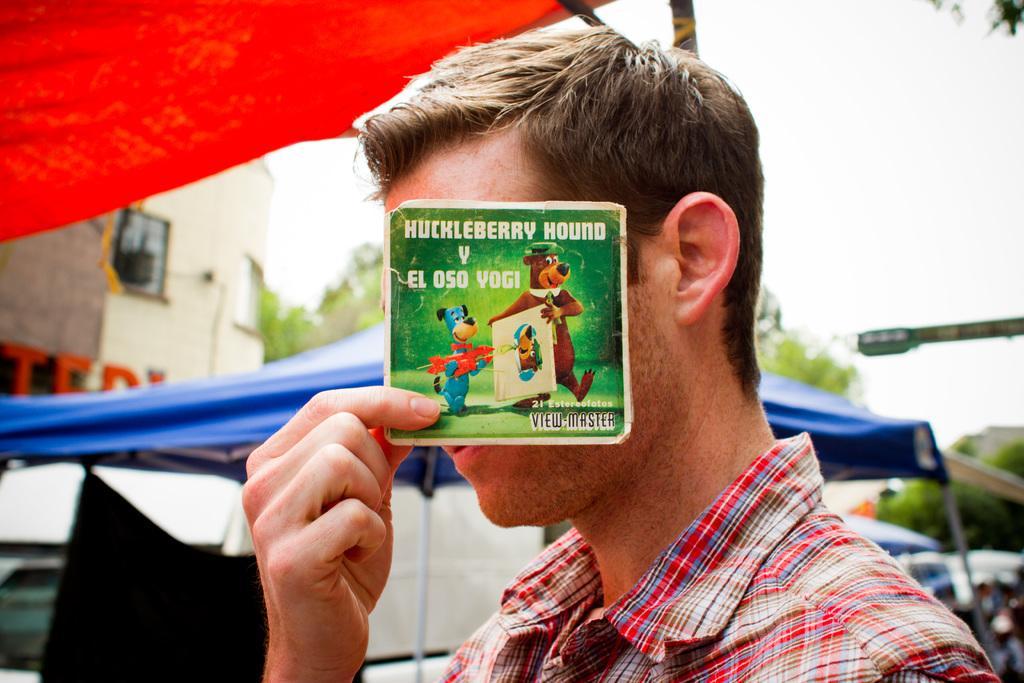Can you describe this image briefly? In this image there is a man in the middle who is hiding his face with the card. On the card there are cartoon images and some text. In the background there are tents. On the left side there is a building in the background. Beside the building there are trees. 